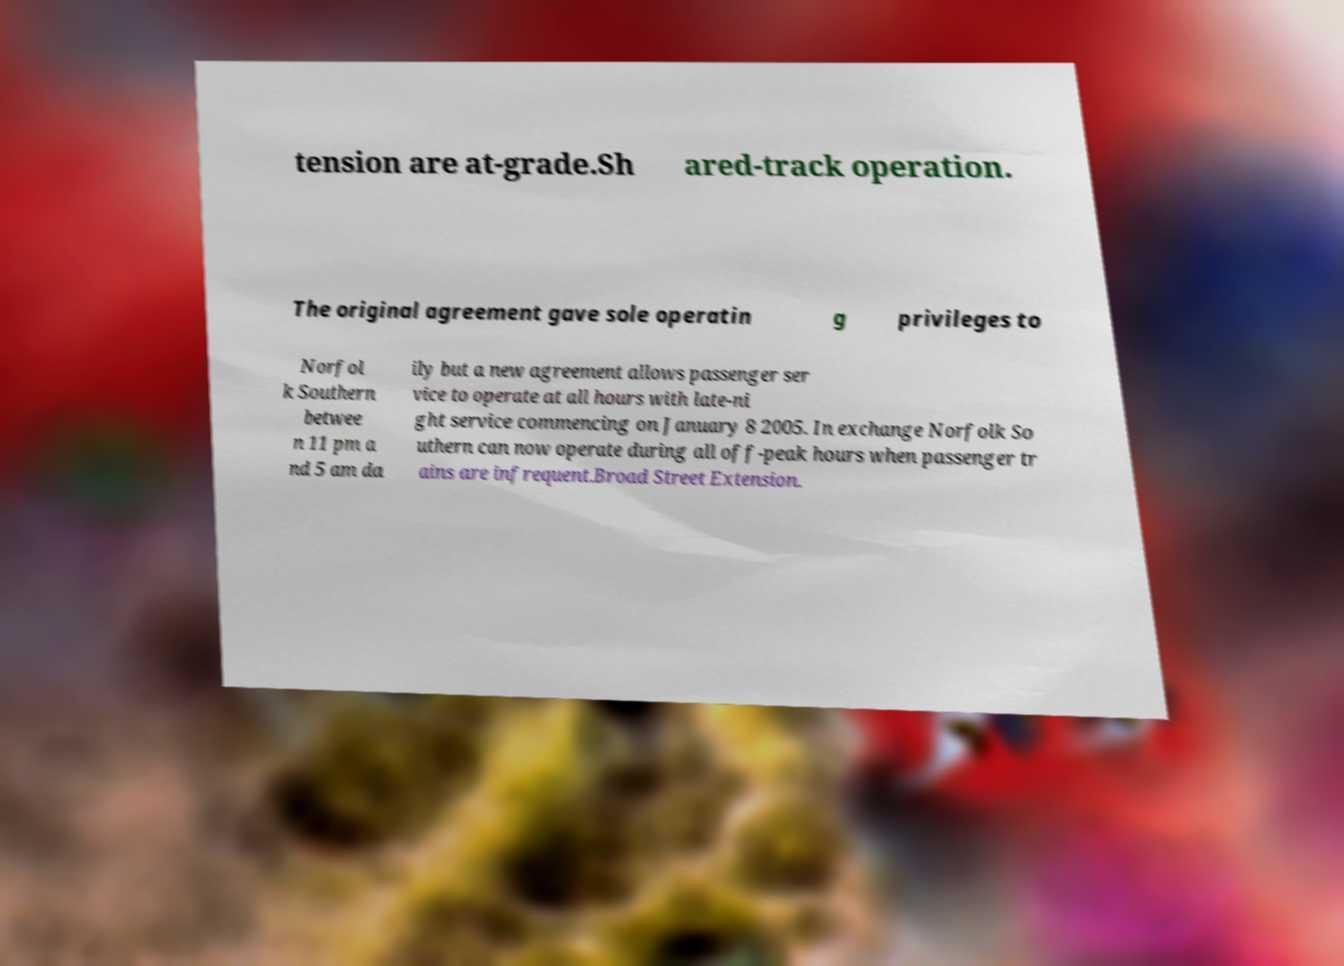Could you extract and type out the text from this image? tension are at-grade.Sh ared-track operation. The original agreement gave sole operatin g privileges to Norfol k Southern betwee n 11 pm a nd 5 am da ily but a new agreement allows passenger ser vice to operate at all hours with late-ni ght service commencing on January 8 2005. In exchange Norfolk So uthern can now operate during all off-peak hours when passenger tr ains are infrequent.Broad Street Extension. 